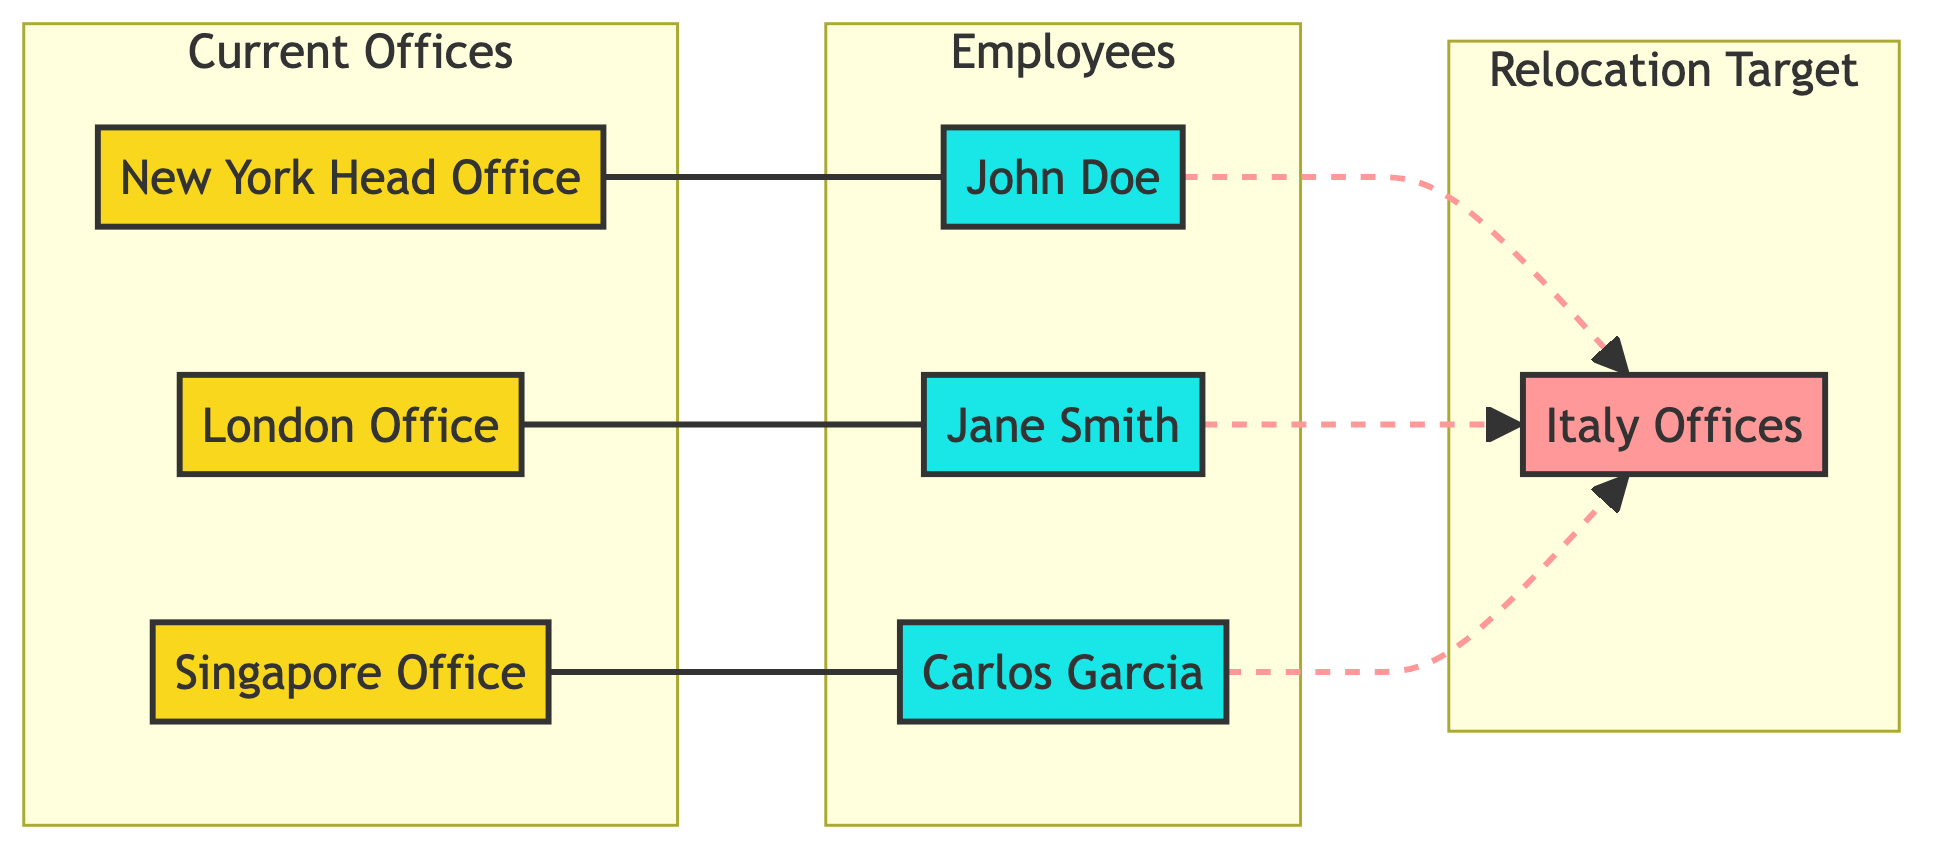What are the current office locations depicted in the diagram? The diagram includes three current office locations: New York Head Office, London Office, and Singapore Office. This information can be found by examining the nodes within the "Current Offices" subgraph.
Answer: New York Head Office, London Office, Singapore Office How many employees are represented in the diagram? There are three employees represented in the diagram: John Doe, Jane Smith, and Carlos Garcia. By counting the nodes in the "Employees" subgraph, we find the total number of employees.
Answer: 3 What is the relationship between John Doe and the New York Head Office? The diagram shows that John Doe is employed by the New York Head Office, as indicated by the edge that connects these two nodes with the "employs" relationship.
Answer: employs From which office is Jane Smith relocating? Jane Smith is relocating from the London Office, as indicated by the edge connecting her node to the Italy Offices node. This node shows that she is moving to Italy from the London Office.
Answer: London Office How many employees are relocating to Italy? All three employees—John Doe, Jane Smith, and Carlos Garcia—are relocating to Italy, confirmed by the edges connecting each employee node to the Italy Offices node. Thus, the total number of relocating employees is three.
Answer: 3 Which type of node has a dashed connection to Italy Offices? The dashed connections to Italy Offices represent the employees relocating to Italy. Since this specifically indicates the kind of relationship, we identify that the dashed line signifies employees and their relocation intent.
Answer: Employees What type of graph is displayed in the diagram? The diagram is an undirected graph, characterized by the lack of directional significance in the edges. All connections can be traversed freely without a direction indicated beside them.
Answer: Undirected graph Which employee is linked to the Singapore Office? Carlos Garcia is the employee linked to the Singapore Office, as indicated by the direct edge that connects Carlos Garcia's node to the Singapore Office node.
Answer: Carlos Garcia 